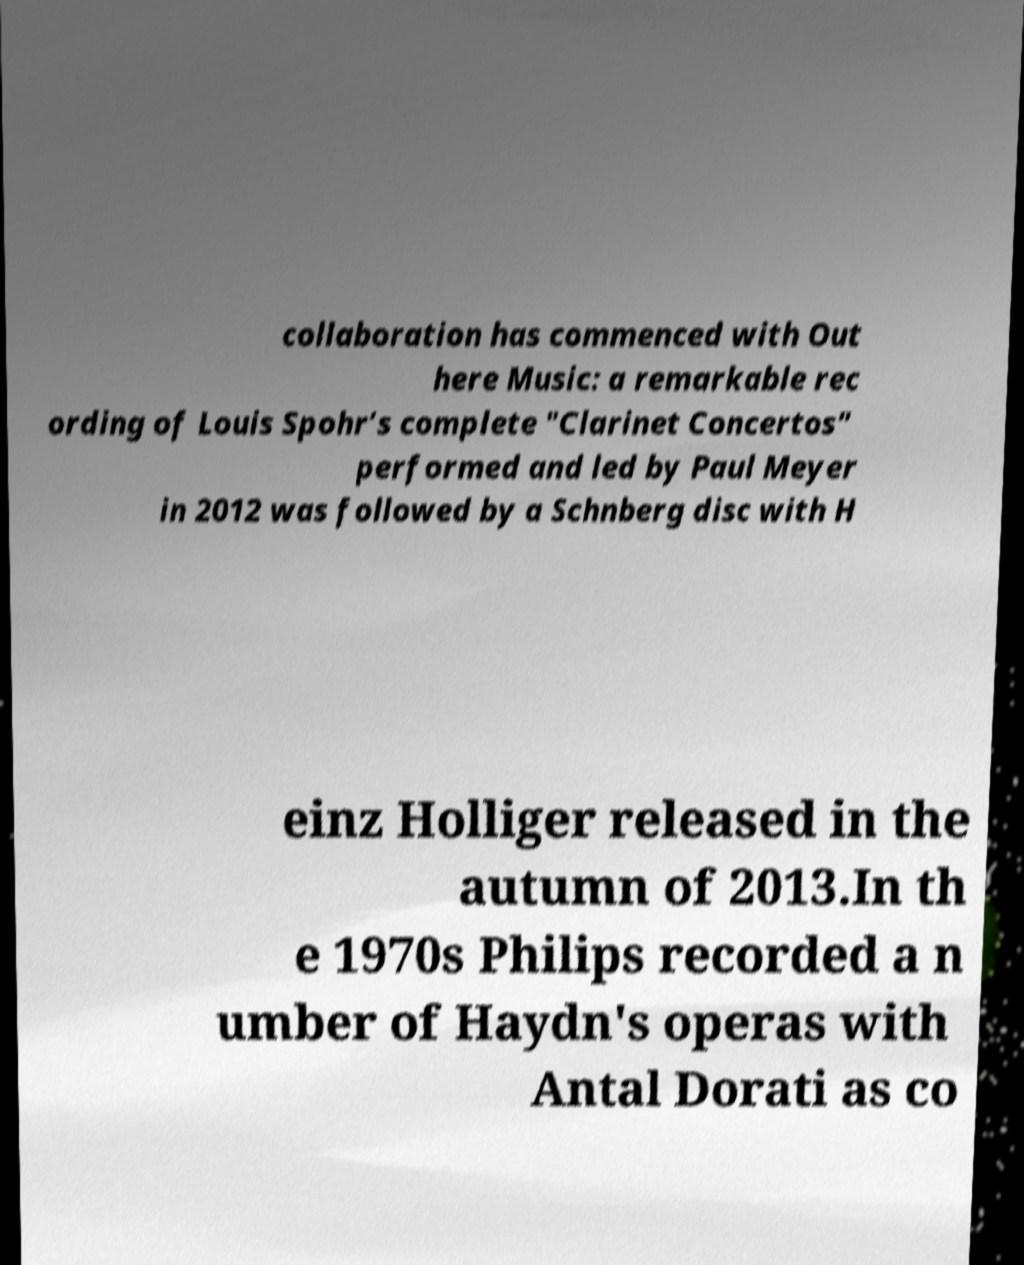Could you extract and type out the text from this image? collaboration has commenced with Out here Music: a remarkable rec ording of Louis Spohr’s complete "Clarinet Concertos" performed and led by Paul Meyer in 2012 was followed by a Schnberg disc with H einz Holliger released in the autumn of 2013.In th e 1970s Philips recorded a n umber of Haydn's operas with Antal Dorati as co 